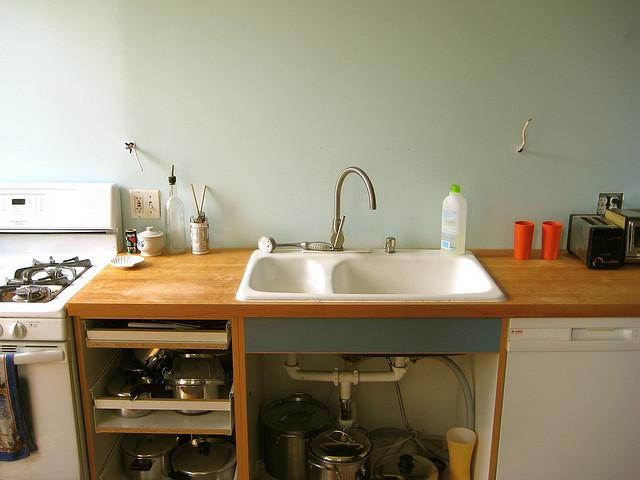What would someone most likely clean in this room?

Choices:
A) clothes
B) body
C) dishes
D) car dishes 